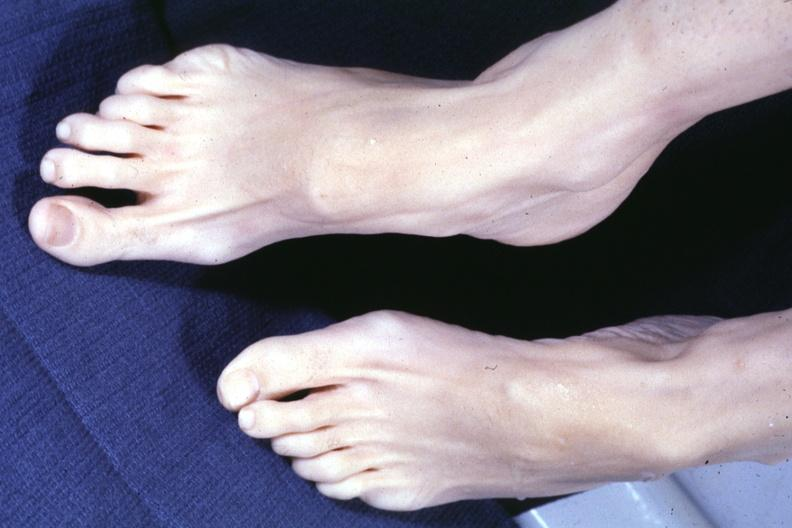what does this image show?
Answer the question using a single word or phrase. Both feet with aortic dissection and mitral prolapse extremities which suggest marfans 